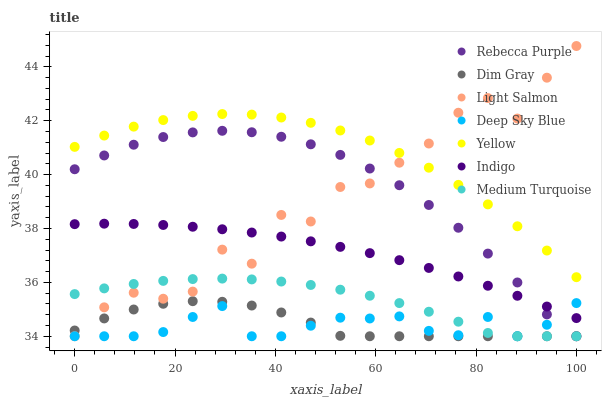Does Deep Sky Blue have the minimum area under the curve?
Answer yes or no. Yes. Does Yellow have the maximum area under the curve?
Answer yes or no. Yes. Does Dim Gray have the minimum area under the curve?
Answer yes or no. No. Does Dim Gray have the maximum area under the curve?
Answer yes or no. No. Is Indigo the smoothest?
Answer yes or no. Yes. Is Light Salmon the roughest?
Answer yes or no. Yes. Is Dim Gray the smoothest?
Answer yes or no. No. Is Dim Gray the roughest?
Answer yes or no. No. Does Light Salmon have the lowest value?
Answer yes or no. Yes. Does Indigo have the lowest value?
Answer yes or no. No. Does Light Salmon have the highest value?
Answer yes or no. Yes. Does Dim Gray have the highest value?
Answer yes or no. No. Is Medium Turquoise less than Yellow?
Answer yes or no. Yes. Is Yellow greater than Dim Gray?
Answer yes or no. Yes. Does Rebecca Purple intersect Light Salmon?
Answer yes or no. Yes. Is Rebecca Purple less than Light Salmon?
Answer yes or no. No. Is Rebecca Purple greater than Light Salmon?
Answer yes or no. No. Does Medium Turquoise intersect Yellow?
Answer yes or no. No. 